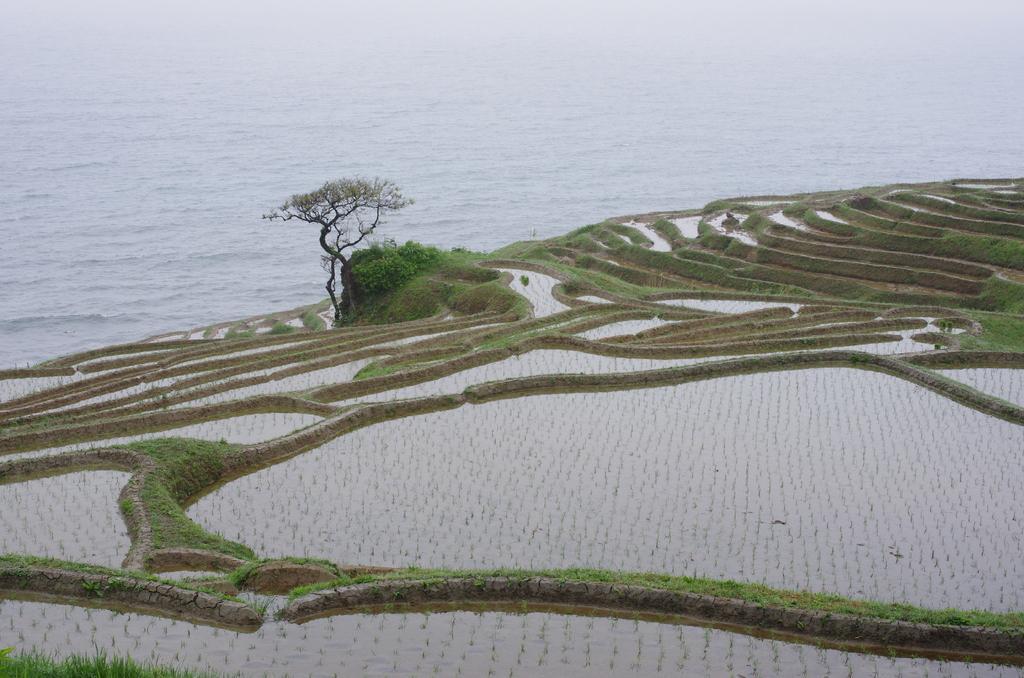How would you summarize this image in a sentence or two? In this image I can see there are crops with water, in the middle it is a tree and this is water 